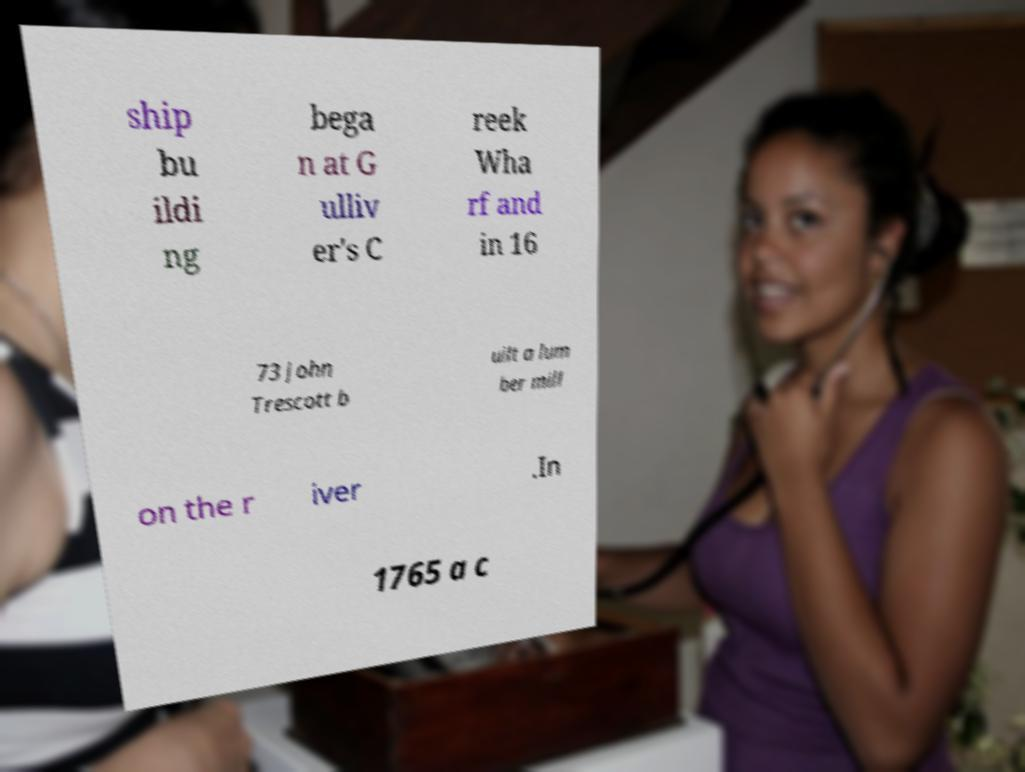Could you extract and type out the text from this image? ship bu ildi ng bega n at G ulliv er's C reek Wha rf and in 16 73 John Trescott b uilt a lum ber mill on the r iver .In 1765 a c 